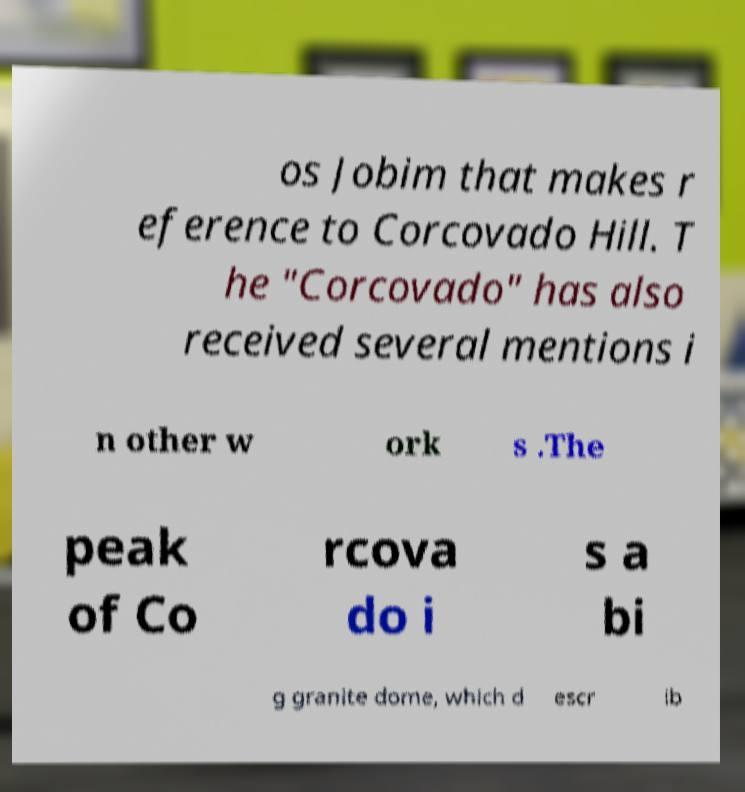Can you read and provide the text displayed in the image?This photo seems to have some interesting text. Can you extract and type it out for me? os Jobim that makes r eference to Corcovado Hill. T he "Corcovado" has also received several mentions i n other w ork s .The peak of Co rcova do i s a bi g granite dome, which d escr ib 